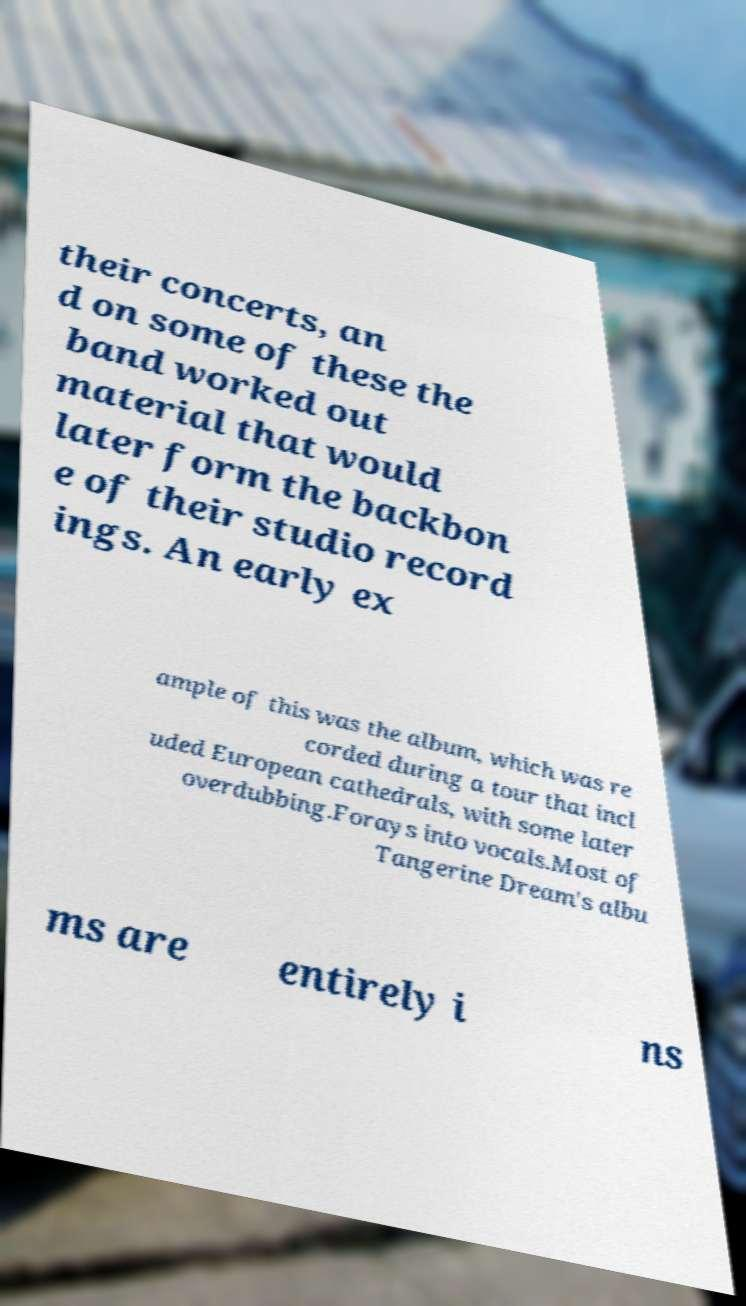Can you read and provide the text displayed in the image?This photo seems to have some interesting text. Can you extract and type it out for me? their concerts, an d on some of these the band worked out material that would later form the backbon e of their studio record ings. An early ex ample of this was the album, which was re corded during a tour that incl uded European cathedrals, with some later overdubbing.Forays into vocals.Most of Tangerine Dream's albu ms are entirely i ns 